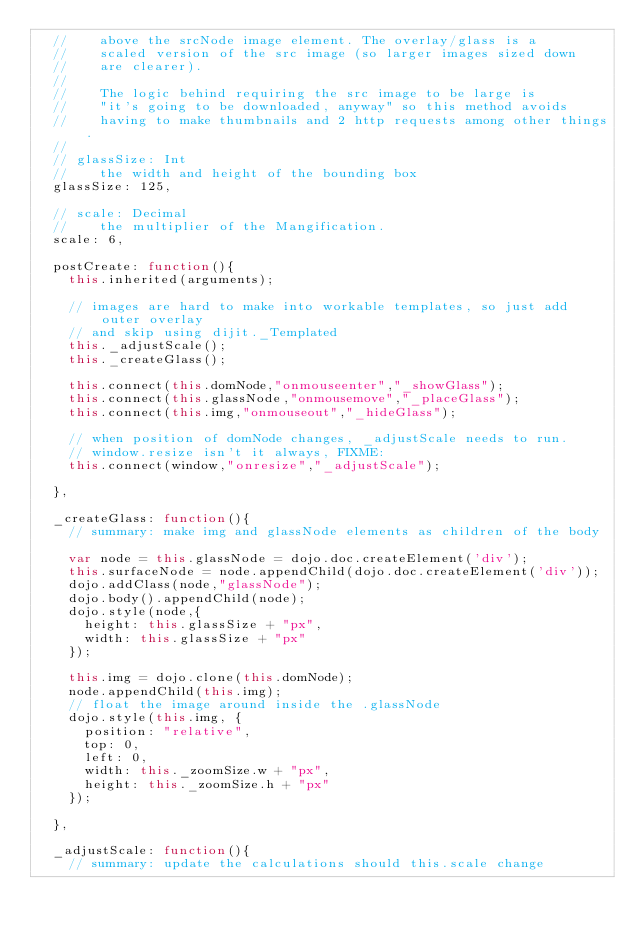Convert code to text. <code><loc_0><loc_0><loc_500><loc_500><_JavaScript_>	// 		above the srcNode image element. The overlay/glass is a 
	//		scaled version of the src image (so larger images sized down
	//		are clearer).
	//
	//		The logic behind requiring the src image to be large is
	//		"it's going to be downloaded, anyway" so this method avoids
	//		having to make thumbnails and 2 http requests among other things.
	//
	// glassSize: Int
	// 		the width and height of the bounding box
	glassSize: 125,

	// scale: Decimal
	// 		the multiplier of the Mangification. 
	scale: 6,

	postCreate: function(){
		this.inherited(arguments);
		
		// images are hard to make into workable templates, so just add outer overlay
		// and skip using dijit._Templated		
		this._adjustScale();
		this._createGlass();
		
		this.connect(this.domNode,"onmouseenter","_showGlass");
		this.connect(this.glassNode,"onmousemove","_placeGlass");
		this.connect(this.img,"onmouseout","_hideGlass");

		// when position of domNode changes, _adjustScale needs to run.
		// window.resize isn't it always, FIXME:
		this.connect(window,"onresize","_adjustScale");
		
	},

	_createGlass: function(){
		// summary: make img and glassNode elements as children of the body

		var node = this.glassNode = dojo.doc.createElement('div');
		this.surfaceNode = node.appendChild(dojo.doc.createElement('div'));
		dojo.addClass(node,"glassNode");
		dojo.body().appendChild(node);
		dojo.style(node,{
			height: this.glassSize + "px",
			width: this.glassSize + "px"
		});
		
		this.img = dojo.clone(this.domNode);
		node.appendChild(this.img);
		// float the image around inside the .glassNode 
		dojo.style(this.img, {
			position: "relative",
			top: 0,
			left: 0,
			width: this._zoomSize.w + "px",
			height: this._zoomSize.h + "px"
		});

	},
	
	_adjustScale: function(){
		// summary: update the calculations should this.scale change
</code> 